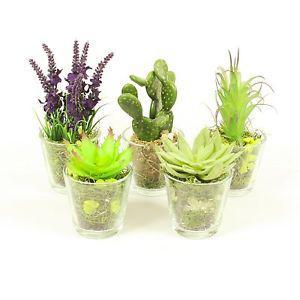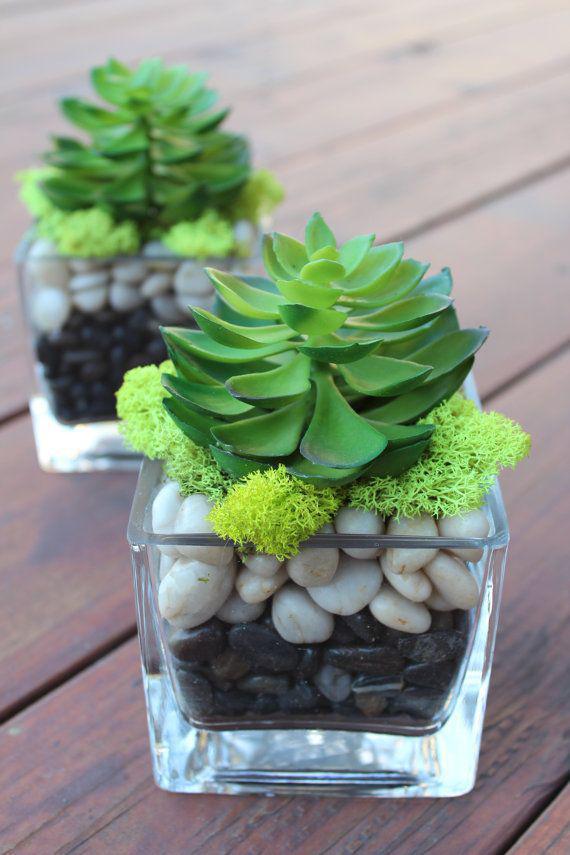The first image is the image on the left, the second image is the image on the right. Considering the images on both sides, is "There are at least two square glass holders with small green shrubbery and rock." valid? Answer yes or no. Yes. The first image is the image on the left, the second image is the image on the right. Evaluate the accuracy of this statement regarding the images: "There are more containers holding plants in the image on the left.". Is it true? Answer yes or no. Yes. 